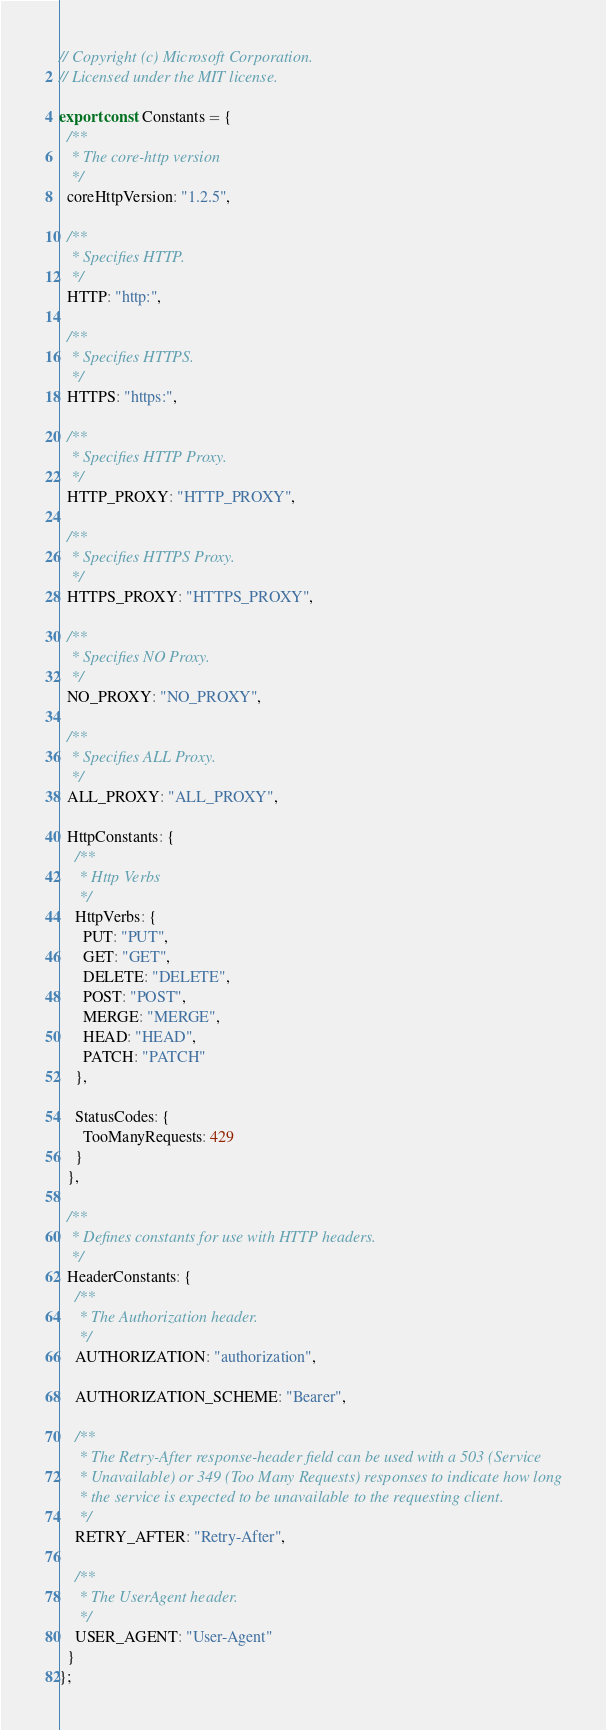<code> <loc_0><loc_0><loc_500><loc_500><_TypeScript_>// Copyright (c) Microsoft Corporation.
// Licensed under the MIT license.

export const Constants = {
  /**
   * The core-http version
   */
  coreHttpVersion: "1.2.5",

  /**
   * Specifies HTTP.
   */
  HTTP: "http:",

  /**
   * Specifies HTTPS.
   */
  HTTPS: "https:",

  /**
   * Specifies HTTP Proxy.
   */
  HTTP_PROXY: "HTTP_PROXY",

  /**
   * Specifies HTTPS Proxy.
   */
  HTTPS_PROXY: "HTTPS_PROXY",

  /**
   * Specifies NO Proxy.
   */
  NO_PROXY: "NO_PROXY",

  /**
   * Specifies ALL Proxy.
   */
  ALL_PROXY: "ALL_PROXY",

  HttpConstants: {
    /**
     * Http Verbs
     */
    HttpVerbs: {
      PUT: "PUT",
      GET: "GET",
      DELETE: "DELETE",
      POST: "POST",
      MERGE: "MERGE",
      HEAD: "HEAD",
      PATCH: "PATCH"
    },

    StatusCodes: {
      TooManyRequests: 429
    }
  },

  /**
   * Defines constants for use with HTTP headers.
   */
  HeaderConstants: {
    /**
     * The Authorization header.
     */
    AUTHORIZATION: "authorization",

    AUTHORIZATION_SCHEME: "Bearer",

    /**
     * The Retry-After response-header field can be used with a 503 (Service
     * Unavailable) or 349 (Too Many Requests) responses to indicate how long
     * the service is expected to be unavailable to the requesting client.
     */
    RETRY_AFTER: "Retry-After",

    /**
     * The UserAgent header.
     */
    USER_AGENT: "User-Agent"
  }
};
</code> 